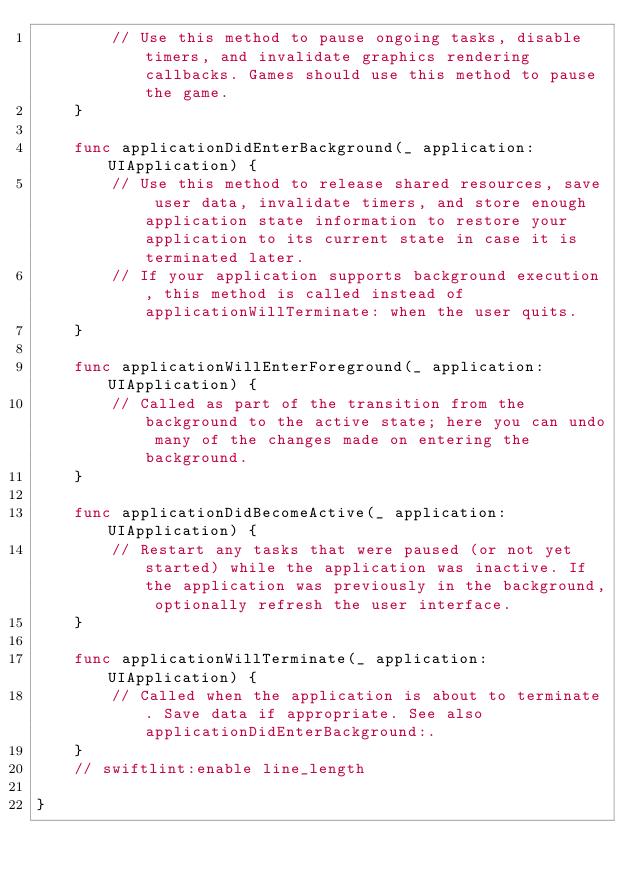Convert code to text. <code><loc_0><loc_0><loc_500><loc_500><_Swift_>        // Use this method to pause ongoing tasks, disable timers, and invalidate graphics rendering callbacks. Games should use this method to pause the game.
    }

    func applicationDidEnterBackground(_ application: UIApplication) {
        // Use this method to release shared resources, save user data, invalidate timers, and store enough application state information to restore your application to its current state in case it is terminated later.
        // If your application supports background execution, this method is called instead of applicationWillTerminate: when the user quits.
    }

    func applicationWillEnterForeground(_ application: UIApplication) {
        // Called as part of the transition from the background to the active state; here you can undo many of the changes made on entering the background.
    }

    func applicationDidBecomeActive(_ application: UIApplication) {
        // Restart any tasks that were paused (or not yet started) while the application was inactive. If the application was previously in the background, optionally refresh the user interface.
    }

    func applicationWillTerminate(_ application: UIApplication) {
        // Called when the application is about to terminate. Save data if appropriate. See also applicationDidEnterBackground:.
    }
    // swiftlint:enable line_length

}
</code> 